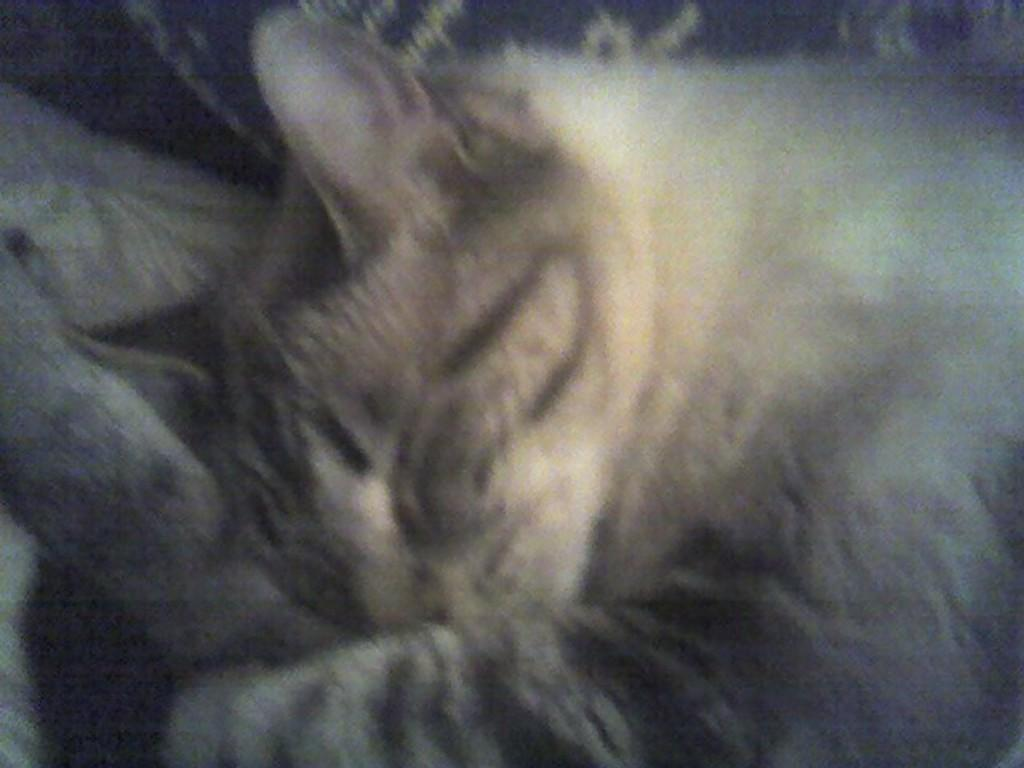What type of animal is in the image? There is a cat in the image. What is the cat doing in the image? The cat is sleeping. Can you describe the quality of the image? The image is blurred. What type of current is flowing through the cat's underwear in the image? There is no mention of underwear or current in the image, as it only features a cat sleeping. 